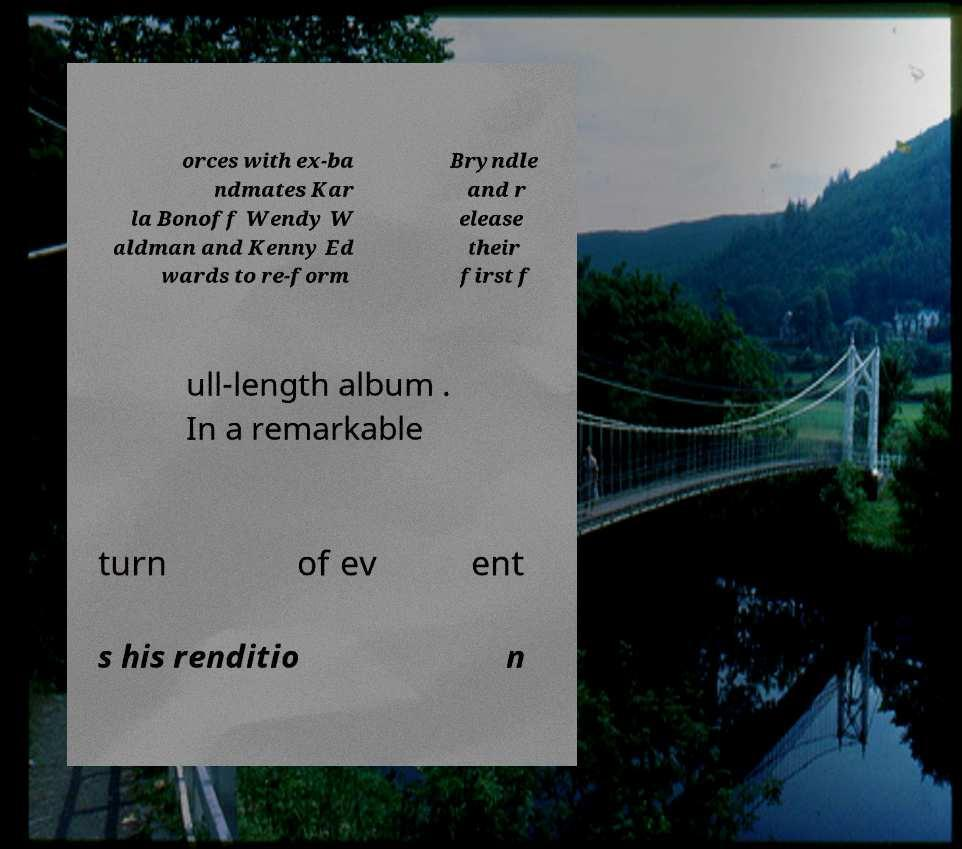For documentation purposes, I need the text within this image transcribed. Could you provide that? orces with ex-ba ndmates Kar la Bonoff Wendy W aldman and Kenny Ed wards to re-form Bryndle and r elease their first f ull-length album . In a remarkable turn of ev ent s his renditio n 